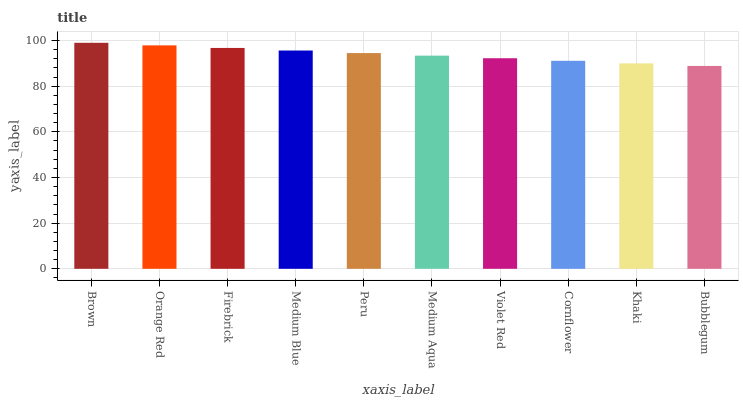Is Orange Red the minimum?
Answer yes or no. No. Is Orange Red the maximum?
Answer yes or no. No. Is Brown greater than Orange Red?
Answer yes or no. Yes. Is Orange Red less than Brown?
Answer yes or no. Yes. Is Orange Red greater than Brown?
Answer yes or no. No. Is Brown less than Orange Red?
Answer yes or no. No. Is Peru the high median?
Answer yes or no. Yes. Is Medium Aqua the low median?
Answer yes or no. Yes. Is Medium Aqua the high median?
Answer yes or no. No. Is Brown the low median?
Answer yes or no. No. 